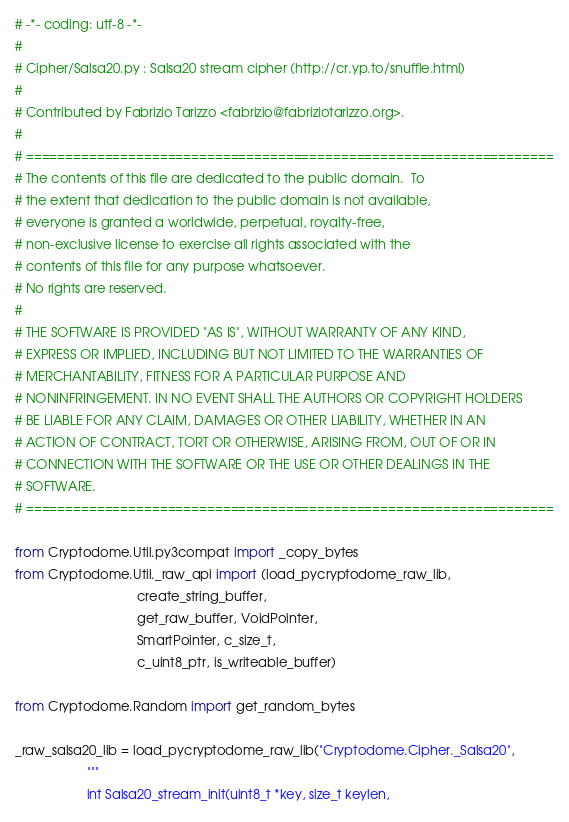Convert code to text. <code><loc_0><loc_0><loc_500><loc_500><_Python_># -*- coding: utf-8 -*-
#
# Cipher/Salsa20.py : Salsa20 stream cipher (http://cr.yp.to/snuffle.html)
#
# Contributed by Fabrizio Tarizzo <fabrizio@fabriziotarizzo.org>.
#
# ===================================================================
# The contents of this file are dedicated to the public domain.  To
# the extent that dedication to the public domain is not available,
# everyone is granted a worldwide, perpetual, royalty-free,
# non-exclusive license to exercise all rights associated with the
# contents of this file for any purpose whatsoever.
# No rights are reserved.
#
# THE SOFTWARE IS PROVIDED "AS IS", WITHOUT WARRANTY OF ANY KIND,
# EXPRESS OR IMPLIED, INCLUDING BUT NOT LIMITED TO THE WARRANTIES OF
# MERCHANTABILITY, FITNESS FOR A PARTICULAR PURPOSE AND
# NONINFRINGEMENT. IN NO EVENT SHALL THE AUTHORS OR COPYRIGHT HOLDERS
# BE LIABLE FOR ANY CLAIM, DAMAGES OR OTHER LIABILITY, WHETHER IN AN
# ACTION OF CONTRACT, TORT OR OTHERWISE, ARISING FROM, OUT OF OR IN
# CONNECTION WITH THE SOFTWARE OR THE USE OR OTHER DEALINGS IN THE
# SOFTWARE.
# ===================================================================

from Cryptodome.Util.py3compat import _copy_bytes
from Cryptodome.Util._raw_api import (load_pycryptodome_raw_lib,
                                  create_string_buffer,
                                  get_raw_buffer, VoidPointer,
                                  SmartPointer, c_size_t,
                                  c_uint8_ptr, is_writeable_buffer)

from Cryptodome.Random import get_random_bytes

_raw_salsa20_lib = load_pycryptodome_raw_lib("Cryptodome.Cipher._Salsa20",
                    """
                    int Salsa20_stream_init(uint8_t *key, size_t keylen,</code> 